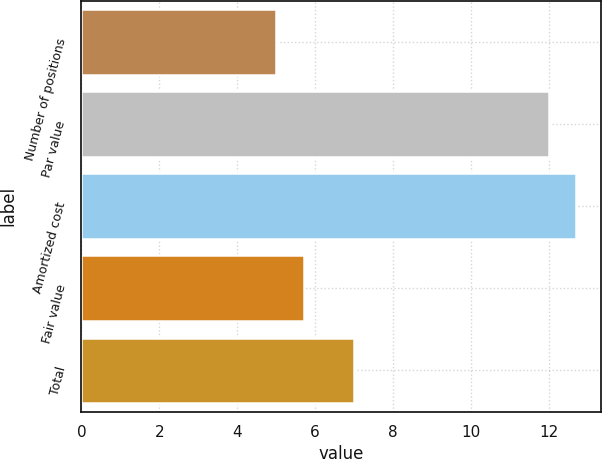<chart> <loc_0><loc_0><loc_500><loc_500><bar_chart><fcel>Number of positions<fcel>Par value<fcel>Amortized cost<fcel>Fair value<fcel>Total<nl><fcel>5<fcel>12<fcel>12.7<fcel>5.7<fcel>7<nl></chart> 